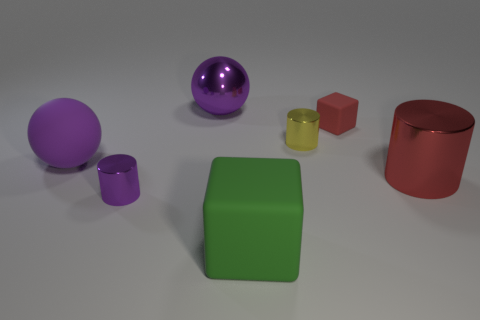What number of cylinders are either large red shiny objects or big green matte things?
Ensure brevity in your answer.  1. What is the shape of the large thing behind the red cube?
Give a very brief answer. Sphere. There is a big matte thing on the left side of the large thing behind the big matte thing that is left of the large green cube; what is its color?
Offer a very short reply. Purple. Is the material of the large green block the same as the red cube?
Ensure brevity in your answer.  Yes. How many green things are large rubber things or cylinders?
Your answer should be compact. 1. There is a big metallic cylinder; what number of small objects are on the left side of it?
Your response must be concise. 3. Is the number of yellow metal cylinders greater than the number of purple spheres?
Ensure brevity in your answer.  No. There is a small metallic object to the left of the large shiny object to the left of the big red shiny cylinder; what is its shape?
Provide a succinct answer. Cylinder. Is the metallic sphere the same color as the large matte sphere?
Your answer should be compact. Yes. Are there more large purple matte balls to the left of the small red matte thing than small purple matte objects?
Ensure brevity in your answer.  Yes. 